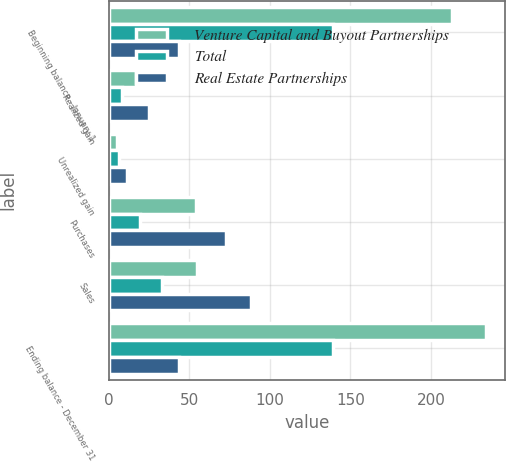Convert chart to OTSL. <chart><loc_0><loc_0><loc_500><loc_500><stacked_bar_chart><ecel><fcel>Beginning balance - January 1<fcel>Realized gain<fcel>Unrealized gain<fcel>Purchases<fcel>Sales<fcel>Ending balance - December 31<nl><fcel>Venture Capital and Buyout Partnerships<fcel>213<fcel>17<fcel>5<fcel>54<fcel>55<fcel>234<nl><fcel>Total<fcel>139<fcel>8<fcel>6<fcel>19<fcel>33<fcel>139<nl><fcel>Real Estate Partnerships<fcel>43.5<fcel>25<fcel>11<fcel>73<fcel>88<fcel>43.5<nl></chart> 